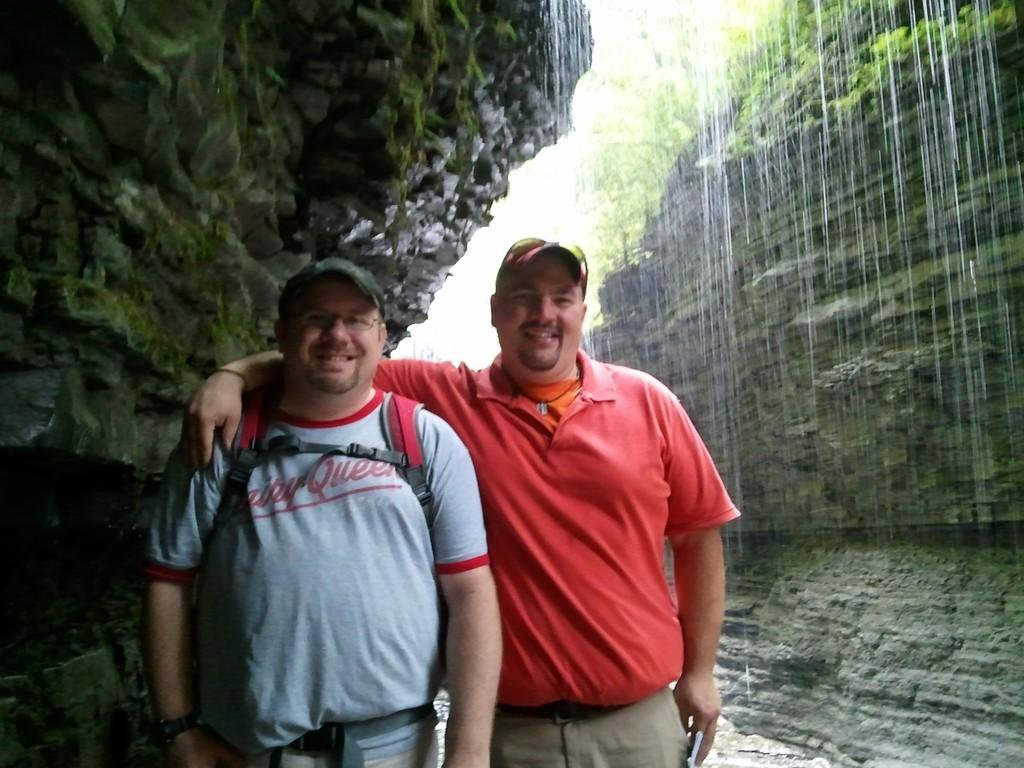<image>
Render a clear and concise summary of the photo. The shirt is bearing the logo of Dairy Queen. 